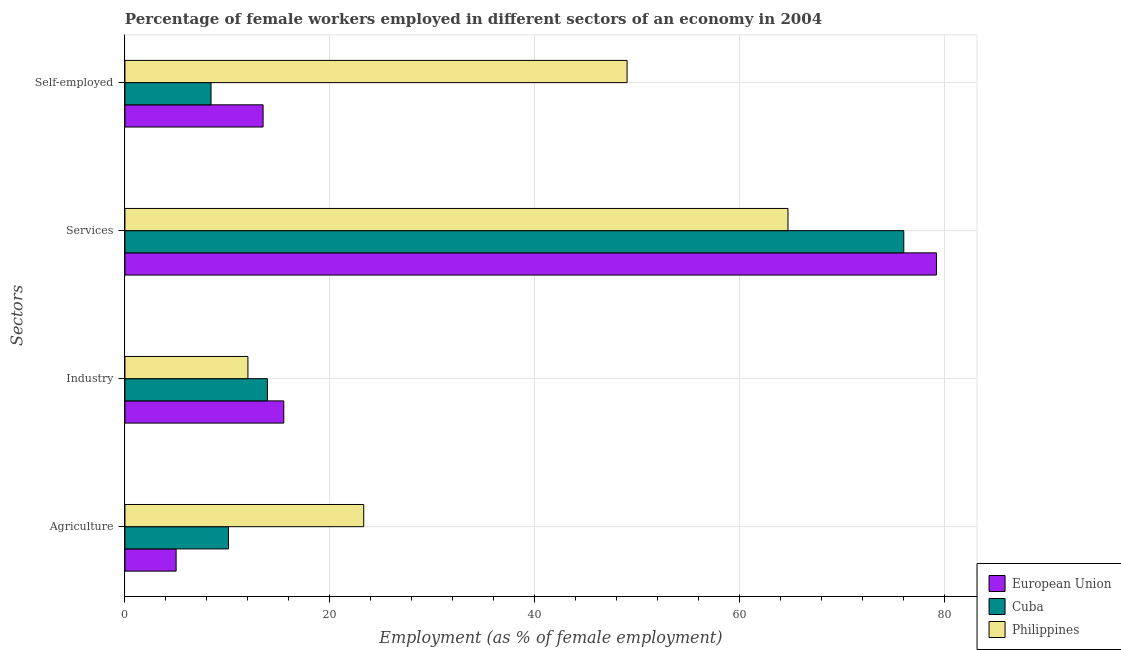How many groups of bars are there?
Provide a short and direct response. 4. Are the number of bars on each tick of the Y-axis equal?
Your answer should be very brief. Yes. How many bars are there on the 2nd tick from the bottom?
Ensure brevity in your answer.  3. What is the label of the 3rd group of bars from the top?
Give a very brief answer. Industry. What is the percentage of female workers in agriculture in European Union?
Your answer should be very brief. 4.99. Across all countries, what is the maximum percentage of female workers in agriculture?
Make the answer very short. 23.3. Across all countries, what is the minimum percentage of female workers in industry?
Your answer should be compact. 12. What is the total percentage of female workers in industry in the graph?
Offer a terse response. 41.4. What is the difference between the percentage of female workers in services in European Union and that in Philippines?
Your answer should be compact. 14.49. What is the difference between the percentage of female workers in services in Cuba and the percentage of female workers in agriculture in Philippines?
Offer a very short reply. 52.7. What is the average percentage of female workers in industry per country?
Make the answer very short. 13.8. What is the difference between the percentage of female workers in industry and percentage of self employed female workers in Cuba?
Make the answer very short. 5.5. What is the ratio of the percentage of female workers in services in European Union to that in Philippines?
Ensure brevity in your answer.  1.22. Is the percentage of female workers in agriculture in European Union less than that in Philippines?
Provide a succinct answer. Yes. Is the difference between the percentage of female workers in services in Cuba and Philippines greater than the difference between the percentage of self employed female workers in Cuba and Philippines?
Ensure brevity in your answer.  Yes. What is the difference between the highest and the second highest percentage of female workers in services?
Ensure brevity in your answer.  3.19. What is the difference between the highest and the lowest percentage of female workers in industry?
Your answer should be compact. 3.5. Is the sum of the percentage of female workers in industry in European Union and Philippines greater than the maximum percentage of female workers in agriculture across all countries?
Ensure brevity in your answer.  Yes. Is it the case that in every country, the sum of the percentage of self employed female workers and percentage of female workers in industry is greater than the sum of percentage of female workers in services and percentage of female workers in agriculture?
Ensure brevity in your answer.  No. What does the 1st bar from the bottom in Services represents?
Your response must be concise. European Union. Is it the case that in every country, the sum of the percentage of female workers in agriculture and percentage of female workers in industry is greater than the percentage of female workers in services?
Give a very brief answer. No. Are all the bars in the graph horizontal?
Offer a terse response. Yes. How many countries are there in the graph?
Provide a succinct answer. 3. What is the difference between two consecutive major ticks on the X-axis?
Your response must be concise. 20. Are the values on the major ticks of X-axis written in scientific E-notation?
Offer a very short reply. No. Where does the legend appear in the graph?
Offer a very short reply. Bottom right. How are the legend labels stacked?
Offer a very short reply. Vertical. What is the title of the graph?
Provide a short and direct response. Percentage of female workers employed in different sectors of an economy in 2004. What is the label or title of the X-axis?
Provide a succinct answer. Employment (as % of female employment). What is the label or title of the Y-axis?
Your answer should be very brief. Sectors. What is the Employment (as % of female employment) in European Union in Agriculture?
Provide a short and direct response. 4.99. What is the Employment (as % of female employment) in Cuba in Agriculture?
Provide a succinct answer. 10.1. What is the Employment (as % of female employment) in Philippines in Agriculture?
Ensure brevity in your answer.  23.3. What is the Employment (as % of female employment) of European Union in Industry?
Offer a terse response. 15.5. What is the Employment (as % of female employment) of Cuba in Industry?
Offer a terse response. 13.9. What is the Employment (as % of female employment) of European Union in Services?
Provide a short and direct response. 79.19. What is the Employment (as % of female employment) of Cuba in Services?
Keep it short and to the point. 76. What is the Employment (as % of female employment) of Philippines in Services?
Your answer should be very brief. 64.7. What is the Employment (as % of female employment) in European Union in Self-employed?
Offer a terse response. 13.48. What is the Employment (as % of female employment) of Cuba in Self-employed?
Provide a succinct answer. 8.4. What is the Employment (as % of female employment) of Philippines in Self-employed?
Your answer should be very brief. 49. Across all Sectors, what is the maximum Employment (as % of female employment) of European Union?
Offer a very short reply. 79.19. Across all Sectors, what is the maximum Employment (as % of female employment) of Philippines?
Your response must be concise. 64.7. Across all Sectors, what is the minimum Employment (as % of female employment) in European Union?
Your answer should be very brief. 4.99. Across all Sectors, what is the minimum Employment (as % of female employment) in Cuba?
Make the answer very short. 8.4. Across all Sectors, what is the minimum Employment (as % of female employment) of Philippines?
Provide a succinct answer. 12. What is the total Employment (as % of female employment) in European Union in the graph?
Provide a succinct answer. 113.16. What is the total Employment (as % of female employment) in Cuba in the graph?
Offer a terse response. 108.4. What is the total Employment (as % of female employment) in Philippines in the graph?
Give a very brief answer. 149. What is the difference between the Employment (as % of female employment) in European Union in Agriculture and that in Industry?
Provide a short and direct response. -10.51. What is the difference between the Employment (as % of female employment) of Cuba in Agriculture and that in Industry?
Provide a succinct answer. -3.8. What is the difference between the Employment (as % of female employment) in Philippines in Agriculture and that in Industry?
Offer a terse response. 11.3. What is the difference between the Employment (as % of female employment) of European Union in Agriculture and that in Services?
Keep it short and to the point. -74.2. What is the difference between the Employment (as % of female employment) in Cuba in Agriculture and that in Services?
Offer a very short reply. -65.9. What is the difference between the Employment (as % of female employment) of Philippines in Agriculture and that in Services?
Offer a very short reply. -41.4. What is the difference between the Employment (as % of female employment) in European Union in Agriculture and that in Self-employed?
Make the answer very short. -8.49. What is the difference between the Employment (as % of female employment) in Cuba in Agriculture and that in Self-employed?
Offer a very short reply. 1.7. What is the difference between the Employment (as % of female employment) of Philippines in Agriculture and that in Self-employed?
Provide a short and direct response. -25.7. What is the difference between the Employment (as % of female employment) of European Union in Industry and that in Services?
Give a very brief answer. -63.69. What is the difference between the Employment (as % of female employment) in Cuba in Industry and that in Services?
Your response must be concise. -62.1. What is the difference between the Employment (as % of female employment) in Philippines in Industry and that in Services?
Your answer should be compact. -52.7. What is the difference between the Employment (as % of female employment) of European Union in Industry and that in Self-employed?
Ensure brevity in your answer.  2.02. What is the difference between the Employment (as % of female employment) of Philippines in Industry and that in Self-employed?
Ensure brevity in your answer.  -37. What is the difference between the Employment (as % of female employment) of European Union in Services and that in Self-employed?
Your answer should be very brief. 65.71. What is the difference between the Employment (as % of female employment) in Cuba in Services and that in Self-employed?
Your answer should be very brief. 67.6. What is the difference between the Employment (as % of female employment) of European Union in Agriculture and the Employment (as % of female employment) of Cuba in Industry?
Your answer should be compact. -8.91. What is the difference between the Employment (as % of female employment) of European Union in Agriculture and the Employment (as % of female employment) of Philippines in Industry?
Keep it short and to the point. -7.01. What is the difference between the Employment (as % of female employment) of European Union in Agriculture and the Employment (as % of female employment) of Cuba in Services?
Ensure brevity in your answer.  -71.01. What is the difference between the Employment (as % of female employment) in European Union in Agriculture and the Employment (as % of female employment) in Philippines in Services?
Provide a succinct answer. -59.71. What is the difference between the Employment (as % of female employment) of Cuba in Agriculture and the Employment (as % of female employment) of Philippines in Services?
Ensure brevity in your answer.  -54.6. What is the difference between the Employment (as % of female employment) of European Union in Agriculture and the Employment (as % of female employment) of Cuba in Self-employed?
Offer a terse response. -3.41. What is the difference between the Employment (as % of female employment) in European Union in Agriculture and the Employment (as % of female employment) in Philippines in Self-employed?
Provide a short and direct response. -44.01. What is the difference between the Employment (as % of female employment) of Cuba in Agriculture and the Employment (as % of female employment) of Philippines in Self-employed?
Ensure brevity in your answer.  -38.9. What is the difference between the Employment (as % of female employment) in European Union in Industry and the Employment (as % of female employment) in Cuba in Services?
Provide a succinct answer. -60.5. What is the difference between the Employment (as % of female employment) of European Union in Industry and the Employment (as % of female employment) of Philippines in Services?
Keep it short and to the point. -49.2. What is the difference between the Employment (as % of female employment) in Cuba in Industry and the Employment (as % of female employment) in Philippines in Services?
Your answer should be very brief. -50.8. What is the difference between the Employment (as % of female employment) of European Union in Industry and the Employment (as % of female employment) of Cuba in Self-employed?
Offer a terse response. 7.1. What is the difference between the Employment (as % of female employment) in European Union in Industry and the Employment (as % of female employment) in Philippines in Self-employed?
Offer a very short reply. -33.5. What is the difference between the Employment (as % of female employment) in Cuba in Industry and the Employment (as % of female employment) in Philippines in Self-employed?
Offer a terse response. -35.1. What is the difference between the Employment (as % of female employment) of European Union in Services and the Employment (as % of female employment) of Cuba in Self-employed?
Offer a very short reply. 70.79. What is the difference between the Employment (as % of female employment) of European Union in Services and the Employment (as % of female employment) of Philippines in Self-employed?
Make the answer very short. 30.19. What is the average Employment (as % of female employment) of European Union per Sectors?
Your answer should be very brief. 28.29. What is the average Employment (as % of female employment) of Cuba per Sectors?
Keep it short and to the point. 27.1. What is the average Employment (as % of female employment) of Philippines per Sectors?
Offer a very short reply. 37.25. What is the difference between the Employment (as % of female employment) of European Union and Employment (as % of female employment) of Cuba in Agriculture?
Make the answer very short. -5.11. What is the difference between the Employment (as % of female employment) of European Union and Employment (as % of female employment) of Philippines in Agriculture?
Your answer should be very brief. -18.31. What is the difference between the Employment (as % of female employment) of Cuba and Employment (as % of female employment) of Philippines in Agriculture?
Give a very brief answer. -13.2. What is the difference between the Employment (as % of female employment) of European Union and Employment (as % of female employment) of Cuba in Industry?
Give a very brief answer. 1.6. What is the difference between the Employment (as % of female employment) in European Union and Employment (as % of female employment) in Philippines in Industry?
Offer a terse response. 3.5. What is the difference between the Employment (as % of female employment) of European Union and Employment (as % of female employment) of Cuba in Services?
Your answer should be very brief. 3.19. What is the difference between the Employment (as % of female employment) of European Union and Employment (as % of female employment) of Philippines in Services?
Your response must be concise. 14.49. What is the difference between the Employment (as % of female employment) in European Union and Employment (as % of female employment) in Cuba in Self-employed?
Ensure brevity in your answer.  5.08. What is the difference between the Employment (as % of female employment) of European Union and Employment (as % of female employment) of Philippines in Self-employed?
Offer a terse response. -35.52. What is the difference between the Employment (as % of female employment) of Cuba and Employment (as % of female employment) of Philippines in Self-employed?
Ensure brevity in your answer.  -40.6. What is the ratio of the Employment (as % of female employment) of European Union in Agriculture to that in Industry?
Give a very brief answer. 0.32. What is the ratio of the Employment (as % of female employment) in Cuba in Agriculture to that in Industry?
Make the answer very short. 0.73. What is the ratio of the Employment (as % of female employment) of Philippines in Agriculture to that in Industry?
Give a very brief answer. 1.94. What is the ratio of the Employment (as % of female employment) in European Union in Agriculture to that in Services?
Provide a succinct answer. 0.06. What is the ratio of the Employment (as % of female employment) of Cuba in Agriculture to that in Services?
Offer a very short reply. 0.13. What is the ratio of the Employment (as % of female employment) of Philippines in Agriculture to that in Services?
Make the answer very short. 0.36. What is the ratio of the Employment (as % of female employment) in European Union in Agriculture to that in Self-employed?
Make the answer very short. 0.37. What is the ratio of the Employment (as % of female employment) of Cuba in Agriculture to that in Self-employed?
Provide a succinct answer. 1.2. What is the ratio of the Employment (as % of female employment) of Philippines in Agriculture to that in Self-employed?
Provide a short and direct response. 0.48. What is the ratio of the Employment (as % of female employment) in European Union in Industry to that in Services?
Offer a terse response. 0.2. What is the ratio of the Employment (as % of female employment) in Cuba in Industry to that in Services?
Ensure brevity in your answer.  0.18. What is the ratio of the Employment (as % of female employment) in Philippines in Industry to that in Services?
Give a very brief answer. 0.19. What is the ratio of the Employment (as % of female employment) of European Union in Industry to that in Self-employed?
Make the answer very short. 1.15. What is the ratio of the Employment (as % of female employment) in Cuba in Industry to that in Self-employed?
Keep it short and to the point. 1.65. What is the ratio of the Employment (as % of female employment) in Philippines in Industry to that in Self-employed?
Your answer should be compact. 0.24. What is the ratio of the Employment (as % of female employment) of European Union in Services to that in Self-employed?
Provide a short and direct response. 5.87. What is the ratio of the Employment (as % of female employment) in Cuba in Services to that in Self-employed?
Your answer should be compact. 9.05. What is the ratio of the Employment (as % of female employment) of Philippines in Services to that in Self-employed?
Your answer should be compact. 1.32. What is the difference between the highest and the second highest Employment (as % of female employment) of European Union?
Your answer should be compact. 63.69. What is the difference between the highest and the second highest Employment (as % of female employment) in Cuba?
Make the answer very short. 62.1. What is the difference between the highest and the second highest Employment (as % of female employment) of Philippines?
Keep it short and to the point. 15.7. What is the difference between the highest and the lowest Employment (as % of female employment) of European Union?
Ensure brevity in your answer.  74.2. What is the difference between the highest and the lowest Employment (as % of female employment) of Cuba?
Your response must be concise. 67.6. What is the difference between the highest and the lowest Employment (as % of female employment) of Philippines?
Offer a terse response. 52.7. 